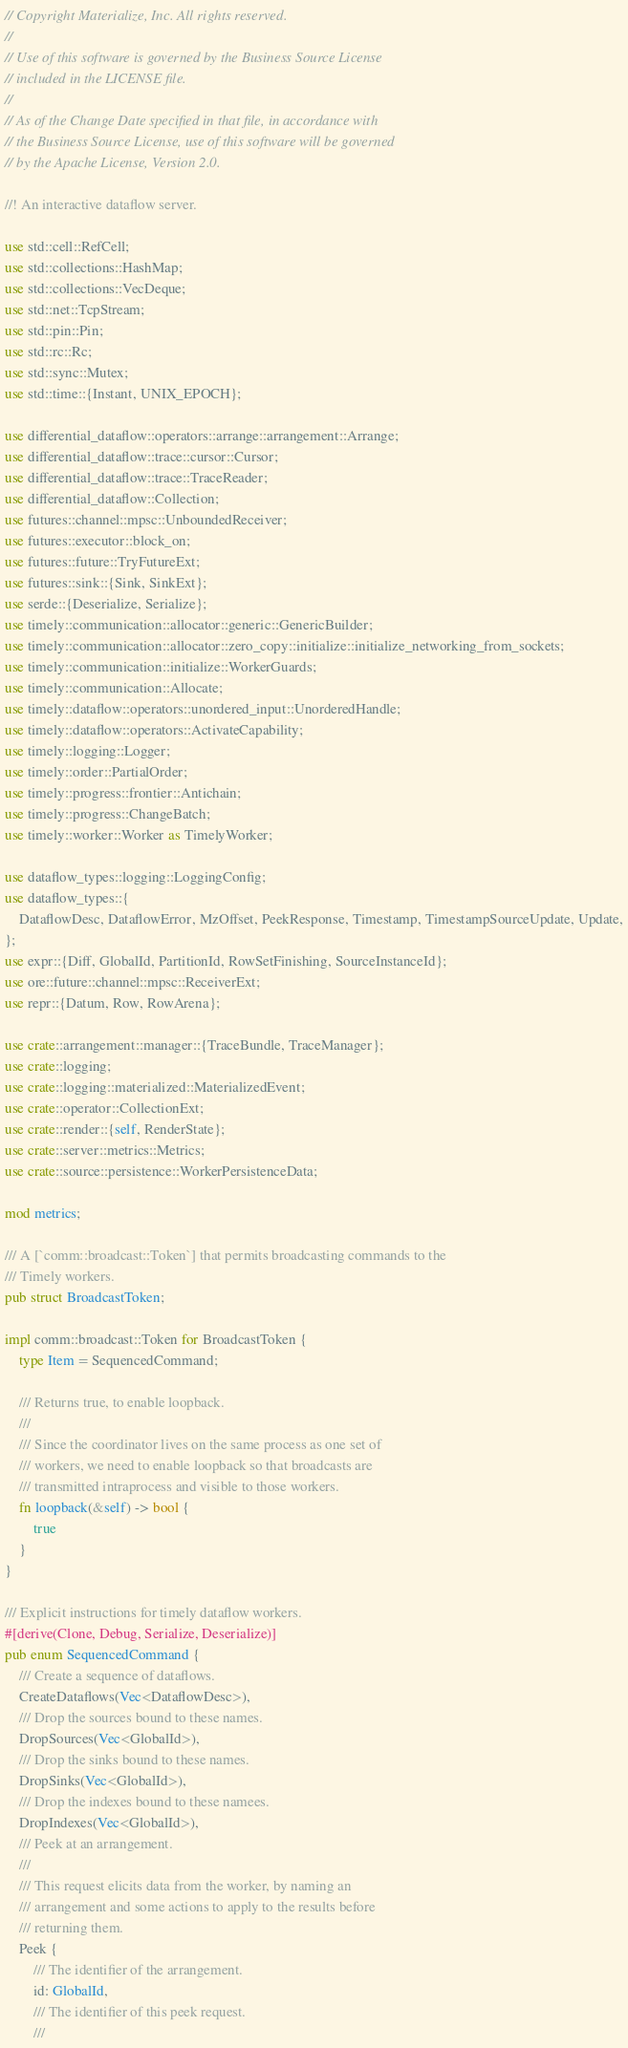<code> <loc_0><loc_0><loc_500><loc_500><_Rust_>// Copyright Materialize, Inc. All rights reserved.
//
// Use of this software is governed by the Business Source License
// included in the LICENSE file.
//
// As of the Change Date specified in that file, in accordance with
// the Business Source License, use of this software will be governed
// by the Apache License, Version 2.0.

//! An interactive dataflow server.

use std::cell::RefCell;
use std::collections::HashMap;
use std::collections::VecDeque;
use std::net::TcpStream;
use std::pin::Pin;
use std::rc::Rc;
use std::sync::Mutex;
use std::time::{Instant, UNIX_EPOCH};

use differential_dataflow::operators::arrange::arrangement::Arrange;
use differential_dataflow::trace::cursor::Cursor;
use differential_dataflow::trace::TraceReader;
use differential_dataflow::Collection;
use futures::channel::mpsc::UnboundedReceiver;
use futures::executor::block_on;
use futures::future::TryFutureExt;
use futures::sink::{Sink, SinkExt};
use serde::{Deserialize, Serialize};
use timely::communication::allocator::generic::GenericBuilder;
use timely::communication::allocator::zero_copy::initialize::initialize_networking_from_sockets;
use timely::communication::initialize::WorkerGuards;
use timely::communication::Allocate;
use timely::dataflow::operators::unordered_input::UnorderedHandle;
use timely::dataflow::operators::ActivateCapability;
use timely::logging::Logger;
use timely::order::PartialOrder;
use timely::progress::frontier::Antichain;
use timely::progress::ChangeBatch;
use timely::worker::Worker as TimelyWorker;

use dataflow_types::logging::LoggingConfig;
use dataflow_types::{
    DataflowDesc, DataflowError, MzOffset, PeekResponse, Timestamp, TimestampSourceUpdate, Update,
};
use expr::{Diff, GlobalId, PartitionId, RowSetFinishing, SourceInstanceId};
use ore::future::channel::mpsc::ReceiverExt;
use repr::{Datum, Row, RowArena};

use crate::arrangement::manager::{TraceBundle, TraceManager};
use crate::logging;
use crate::logging::materialized::MaterializedEvent;
use crate::operator::CollectionExt;
use crate::render::{self, RenderState};
use crate::server::metrics::Metrics;
use crate::source::persistence::WorkerPersistenceData;

mod metrics;

/// A [`comm::broadcast::Token`] that permits broadcasting commands to the
/// Timely workers.
pub struct BroadcastToken;

impl comm::broadcast::Token for BroadcastToken {
    type Item = SequencedCommand;

    /// Returns true, to enable loopback.
    ///
    /// Since the coordinator lives on the same process as one set of
    /// workers, we need to enable loopback so that broadcasts are
    /// transmitted intraprocess and visible to those workers.
    fn loopback(&self) -> bool {
        true
    }
}

/// Explicit instructions for timely dataflow workers.
#[derive(Clone, Debug, Serialize, Deserialize)]
pub enum SequencedCommand {
    /// Create a sequence of dataflows.
    CreateDataflows(Vec<DataflowDesc>),
    /// Drop the sources bound to these names.
    DropSources(Vec<GlobalId>),
    /// Drop the sinks bound to these names.
    DropSinks(Vec<GlobalId>),
    /// Drop the indexes bound to these namees.
    DropIndexes(Vec<GlobalId>),
    /// Peek at an arrangement.
    ///
    /// This request elicits data from the worker, by naming an
    /// arrangement and some actions to apply to the results before
    /// returning them.
    Peek {
        /// The identifier of the arrangement.
        id: GlobalId,
        /// The identifier of this peek request.
        ///</code> 